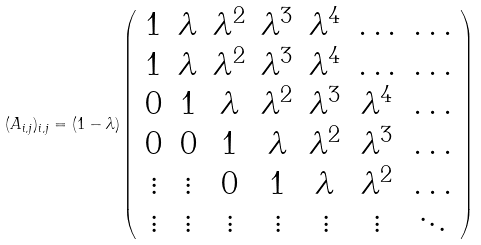<formula> <loc_0><loc_0><loc_500><loc_500>( A _ { i , j } ) _ { i , j } = ( 1 - \lambda ) \left ( \begin{array} { c c c c c c c } 1 & \lambda & \lambda ^ { 2 } & \lambda ^ { 3 } & \lambda ^ { 4 } & \hdots & \hdots \\ 1 & \lambda & \lambda ^ { 2 } & \lambda ^ { 3 } & \lambda ^ { 4 } & \hdots & \hdots \\ 0 & 1 & \lambda & \lambda ^ { 2 } & \lambda ^ { 3 } & \lambda ^ { 4 } & \hdots \\ 0 & 0 & 1 & \lambda & \lambda ^ { 2 } & \lambda ^ { 3 } & \hdots \\ \vdots & \vdots & 0 & 1 & \lambda & \lambda ^ { 2 } & \hdots \\ \vdots & \vdots & \vdots & \vdots & \vdots & \vdots & \ddots \end{array} \right )</formula> 